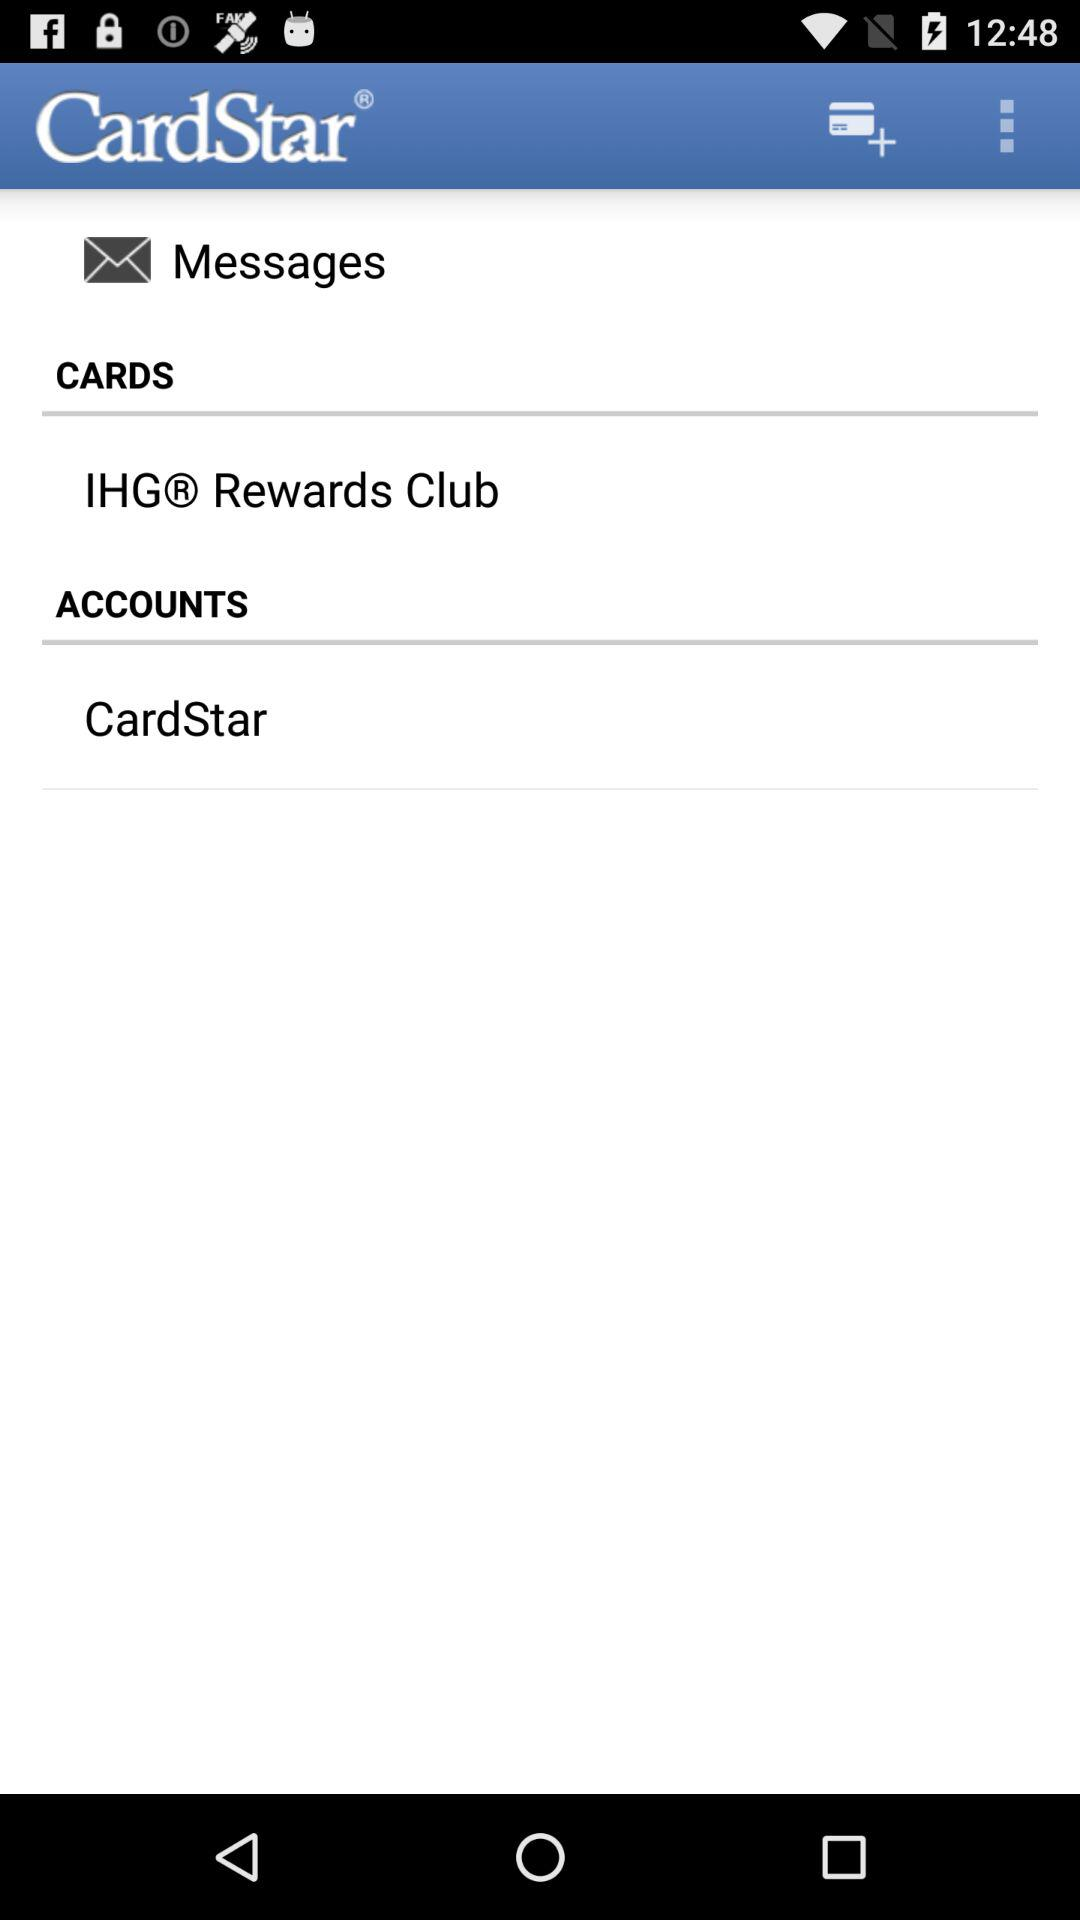What account is used? The used account is "CardStar". 